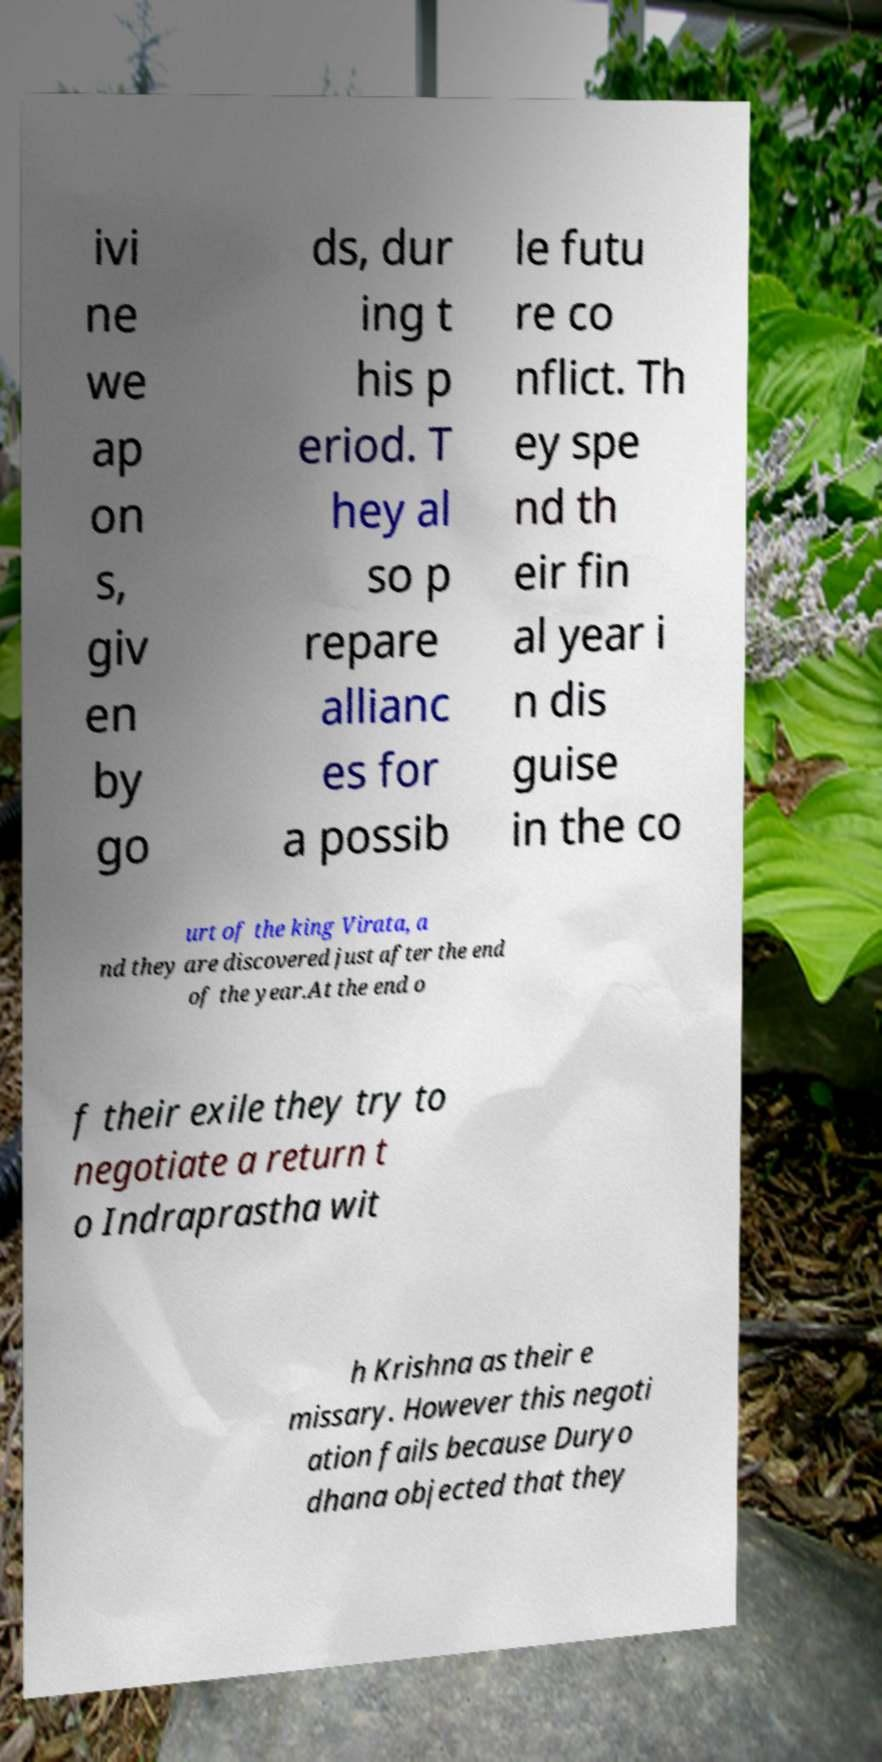For documentation purposes, I need the text within this image transcribed. Could you provide that? ivi ne we ap on s, giv en by go ds, dur ing t his p eriod. T hey al so p repare allianc es for a possib le futu re co nflict. Th ey spe nd th eir fin al year i n dis guise in the co urt of the king Virata, a nd they are discovered just after the end of the year.At the end o f their exile they try to negotiate a return t o Indraprastha wit h Krishna as their e missary. However this negoti ation fails because Duryo dhana objected that they 